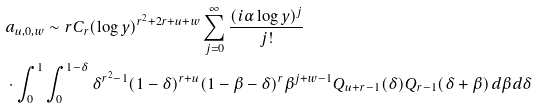<formula> <loc_0><loc_0><loc_500><loc_500>& a _ { u , 0 , w } \sim r C _ { r } ( \log y ) ^ { r ^ { 2 } + 2 r + u + w } \sum _ { j = 0 } ^ { \infty } \frac { ( i \alpha \log y ) ^ { j } } { j ! } \\ & \cdot \int _ { 0 } ^ { 1 } \int _ { 0 } ^ { 1 - \delta } \delta ^ { r ^ { 2 } - 1 } ( 1 - \delta ) ^ { r + u } ( 1 - \beta - \delta ) ^ { r } \beta ^ { j + w - 1 } Q _ { u + r - 1 } ( \delta ) Q _ { r - 1 } ( \delta + \beta ) \, d \beta d \delta</formula> 